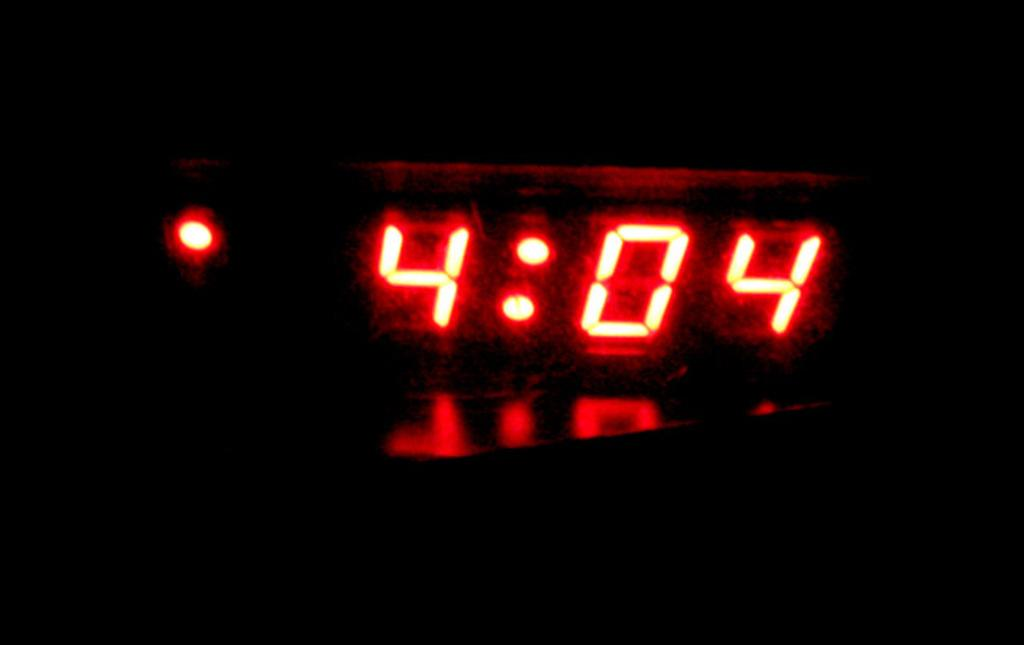Provide a one-sentence caption for the provided image. The time on the digital clock reads 4:04. 